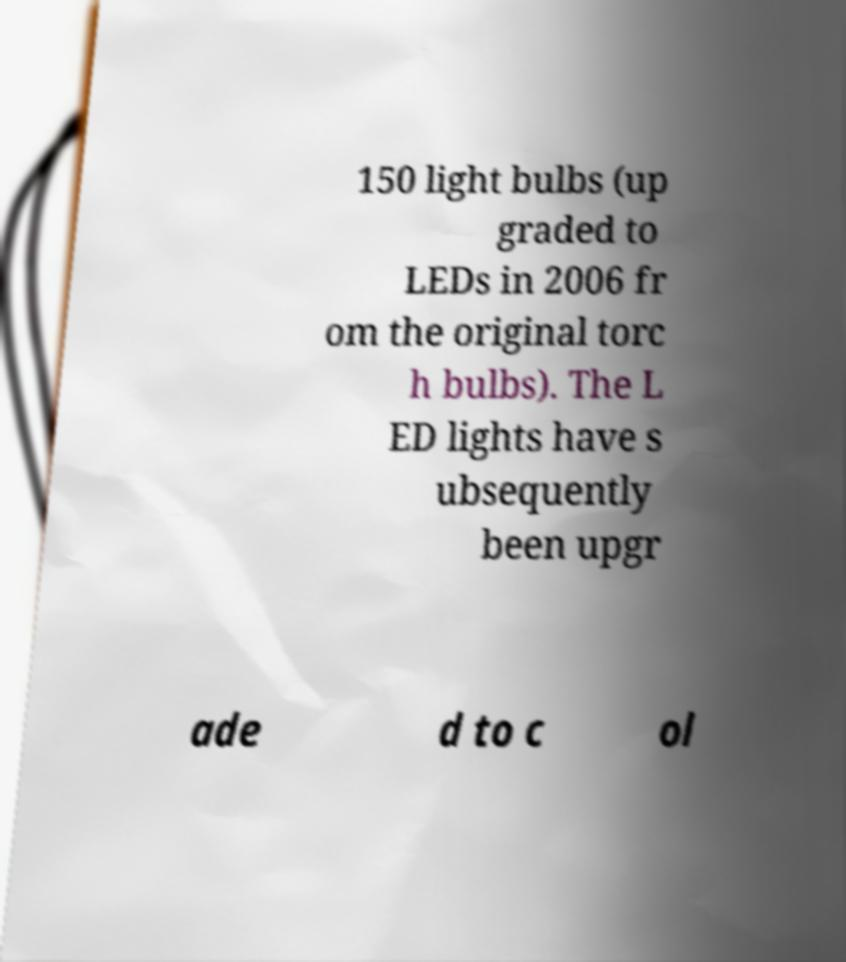Please read and relay the text visible in this image. What does it say? 150 light bulbs (up graded to LEDs in 2006 fr om the original torc h bulbs). The L ED lights have s ubsequently been upgr ade d to c ol 